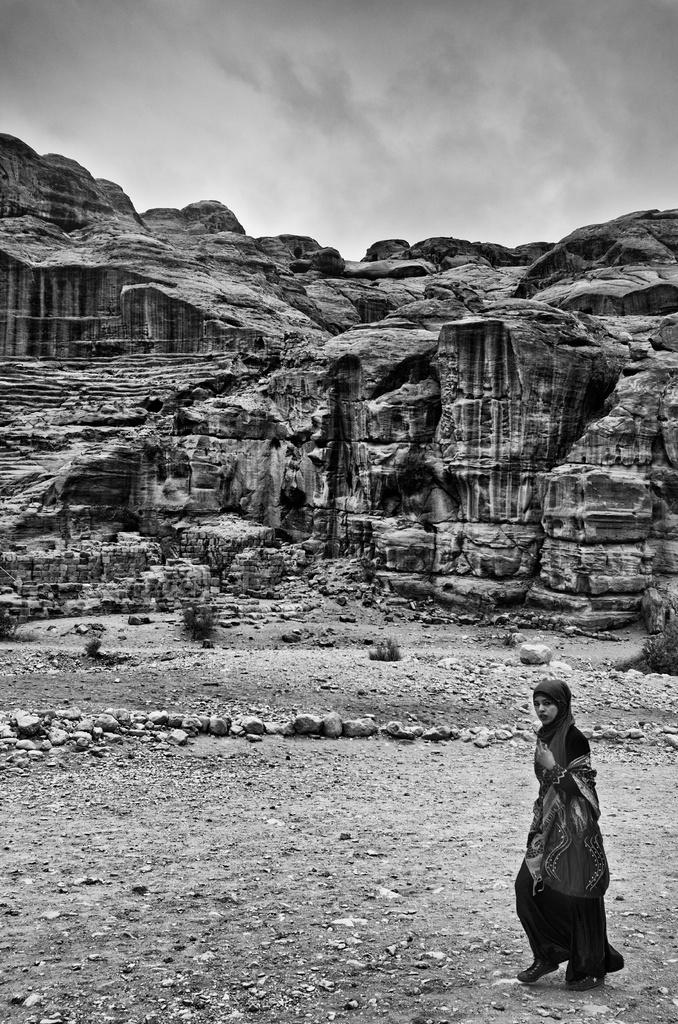What is the color scheme of the image? The image is black and white. What is the woman in the image doing? The woman is walking in the image. What can be seen under the woman's feet? The ground is visible in the image. What type of landscape can be seen in the background? There are stones and a hill in the background of the image. What is visible at the top of the image? The sky is visible at the top of the image. What type of canvas is the woman painting in the image? There is no canvas or painting activity present in the image; it features a woman walking in a black and white landscape. How many boats can be seen sailing in the background of the image? There are no boats visible in the image; it features a woman walking in a landscape with stones, a hill, and the sky. 